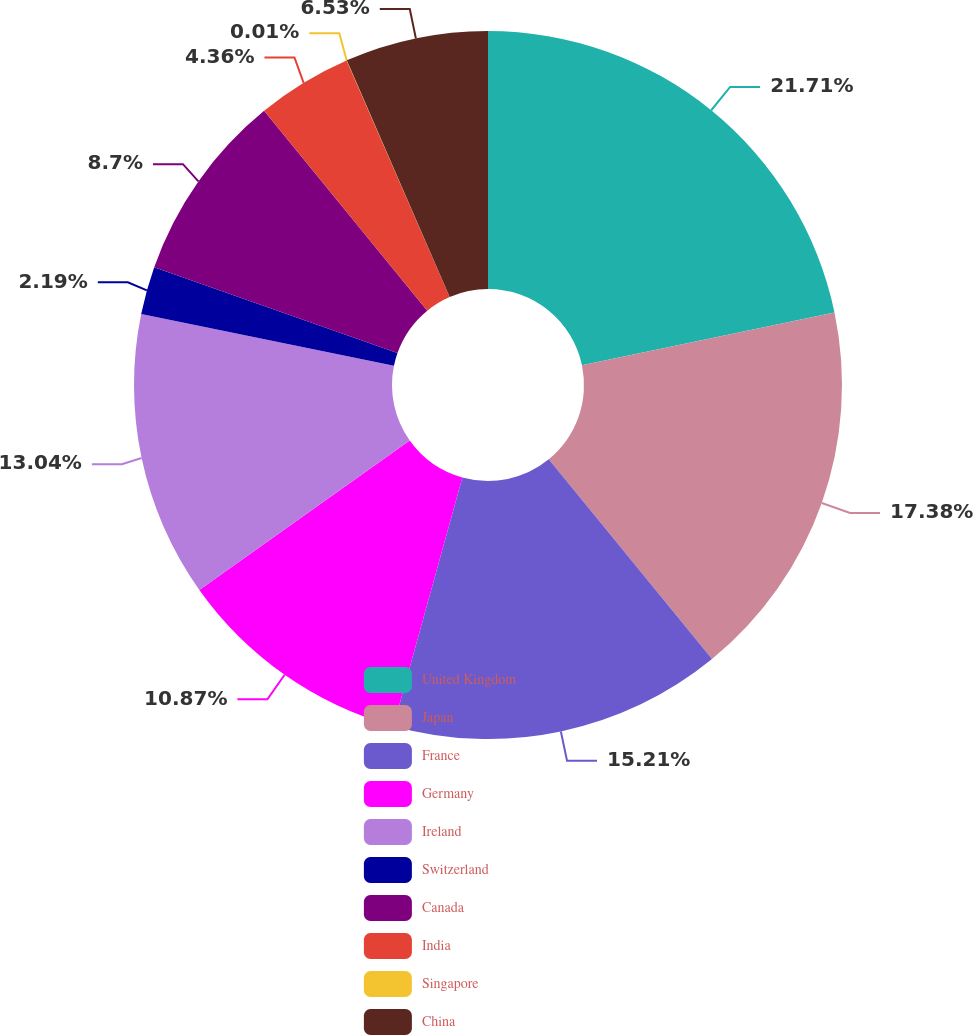Convert chart. <chart><loc_0><loc_0><loc_500><loc_500><pie_chart><fcel>United Kingdom<fcel>Japan<fcel>France<fcel>Germany<fcel>Ireland<fcel>Switzerland<fcel>Canada<fcel>India<fcel>Singapore<fcel>China<nl><fcel>21.72%<fcel>17.38%<fcel>15.21%<fcel>10.87%<fcel>13.04%<fcel>2.19%<fcel>8.7%<fcel>4.36%<fcel>0.01%<fcel>6.53%<nl></chart> 